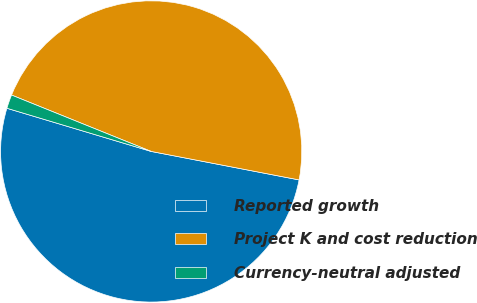Convert chart. <chart><loc_0><loc_0><loc_500><loc_500><pie_chart><fcel>Reported growth<fcel>Project K and cost reduction<fcel>Currency-neutral adjusted<nl><fcel>51.6%<fcel>46.92%<fcel>1.48%<nl></chart> 